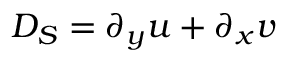<formula> <loc_0><loc_0><loc_500><loc_500>D _ { S } = \partial _ { y } u + \partial _ { x } v</formula> 